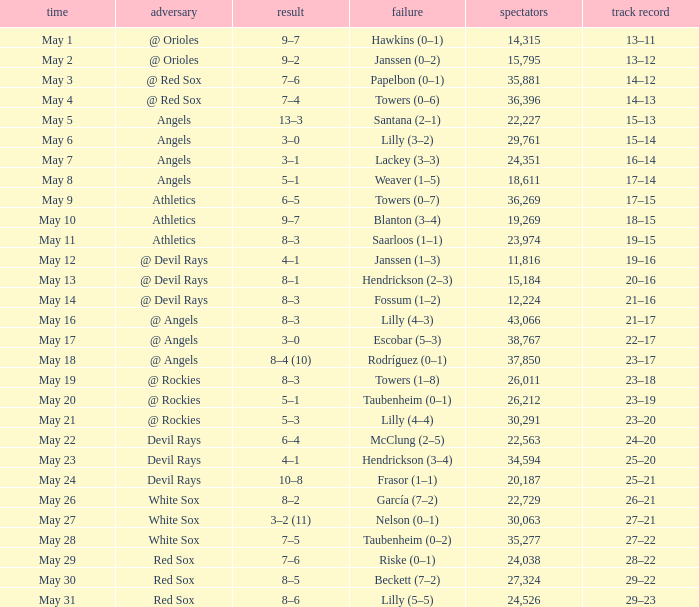What was the average attendance for games with a loss of papelbon (0–1)? 35881.0. 